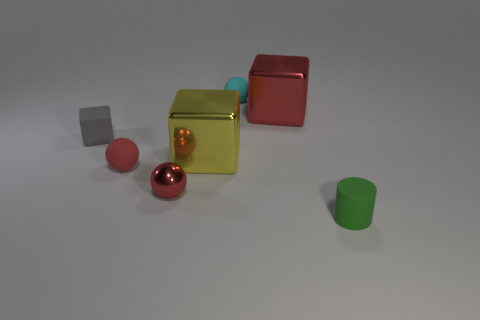What is the shape of the red rubber thing?
Offer a terse response. Sphere. How many other things are there of the same material as the small green object?
Your answer should be compact. 3. What is the color of the matte ball behind the block that is on the right side of the block that is in front of the gray thing?
Keep it short and to the point. Cyan. There is a red block that is the same size as the yellow cube; what material is it?
Give a very brief answer. Metal. How many objects are matte spheres that are behind the small green object or big yellow metal things?
Make the answer very short. 3. Is there a cyan rubber ball?
Offer a very short reply. Yes. There is a red object in front of the red rubber thing; what is it made of?
Provide a short and direct response. Metal. There is a tiny thing that is the same color as the small metallic sphere; what material is it?
Keep it short and to the point. Rubber. How many big objects are either cyan cylinders or red cubes?
Give a very brief answer. 1. What is the color of the tiny metallic object?
Your answer should be compact. Red. 